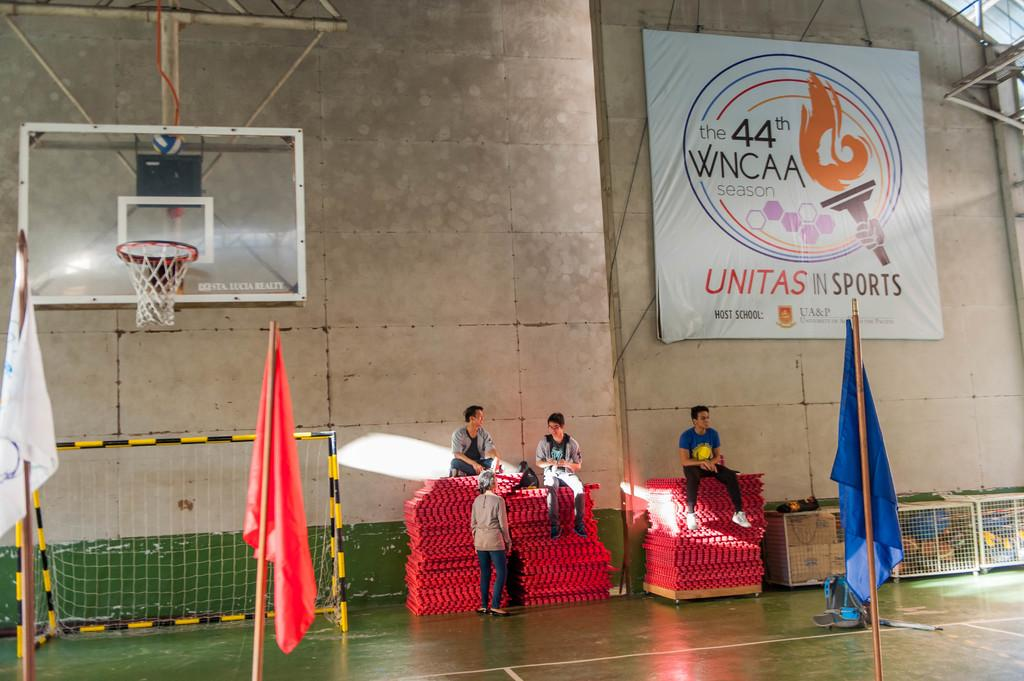Who or what is present in the image? There are people in the image. What is on the wall in the image? There is a board on the wall. What can be seen flying in the image? There are flags visible in the image. What object is present that could be used for catching or blocking? There is a net in the image. Can you tell me how many people are walking in the image? There is no indication of anyone walking in the image; the people are not in motion. 